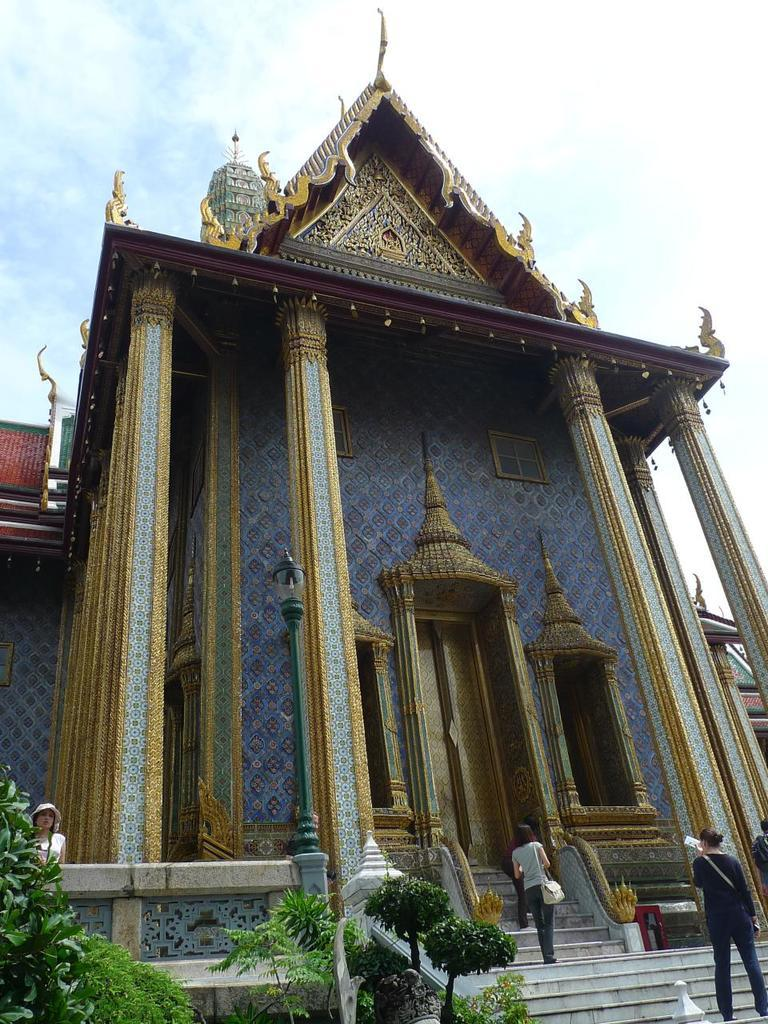What type of structure is visible in the image? There is a building with windows in the image. What can be seen in front of the building? There are people, plants, a light pole, and steps in front of the building. How many elements are present in front of the building? There are five elements present in front of the building: people, plants, a light pole, steps, and the building itself. What is the condition of the sky in the image? The sky is cloudy in the image. What type of channel can be seen running through the building in the image? There is no channel visible in the image; it features a building with windows and elements in front of it. How does the ant affect the acoustics of the building in the image? There is no ant present in the image, so its impact on the building's acoustics cannot be determined. 